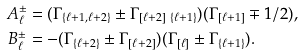Convert formula to latex. <formula><loc_0><loc_0><loc_500><loc_500>A _ { \ell } ^ { \pm } & = ( \Gamma _ { \{ \ell + 1 , \ell + 2 \} } \pm \Gamma _ { [ \ell + 2 ] \ \{ \ell + 1 \} } ) ( \Gamma _ { [ \ell + 1 ] } \mp 1 / 2 ) , \\ B _ { \ell } ^ { \pm } & = - ( \Gamma _ { \{ \ell + 2 \} } \pm \Gamma _ { [ \ell + 2 ] } ) ( \Gamma _ { [ \ell ] } \pm \Gamma _ { \{ \ell + 1 \} } ) .</formula> 